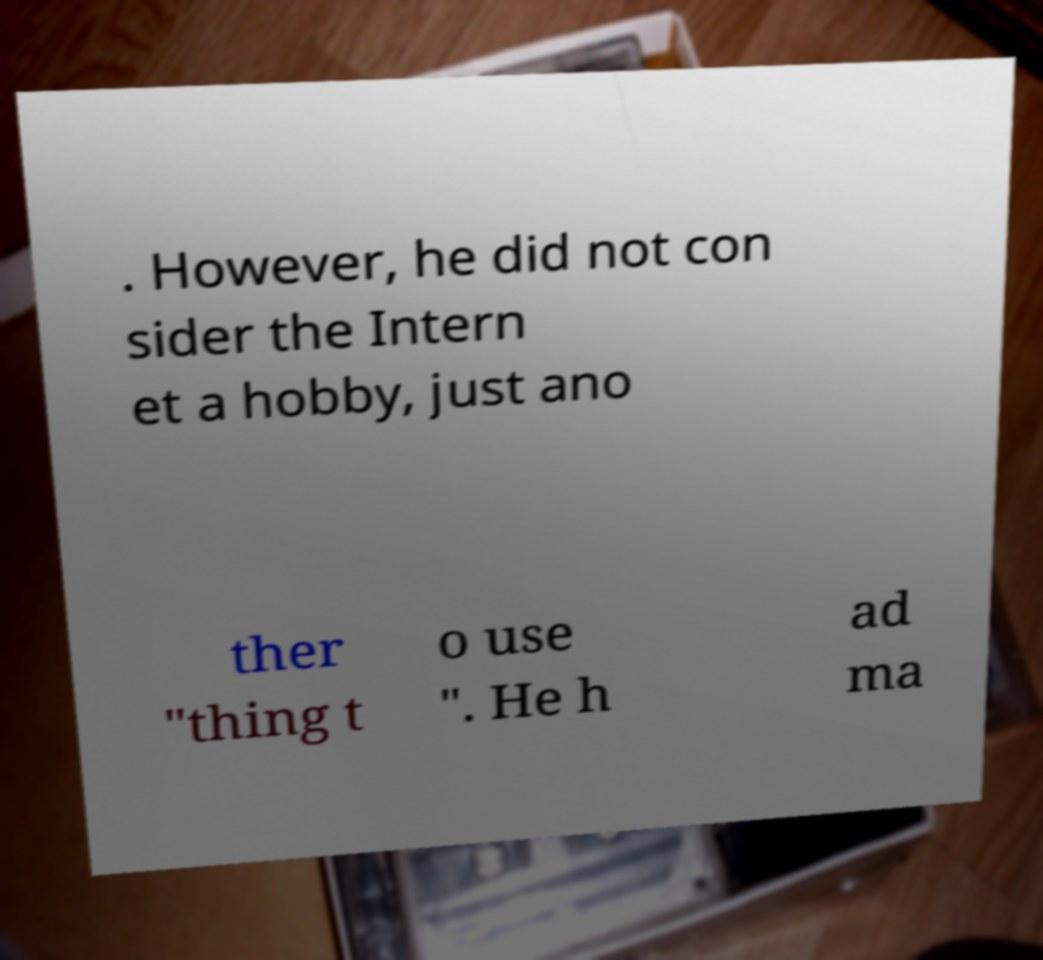Can you read and provide the text displayed in the image?This photo seems to have some interesting text. Can you extract and type it out for me? . However, he did not con sider the Intern et a hobby, just ano ther "thing t o use ". He h ad ma 